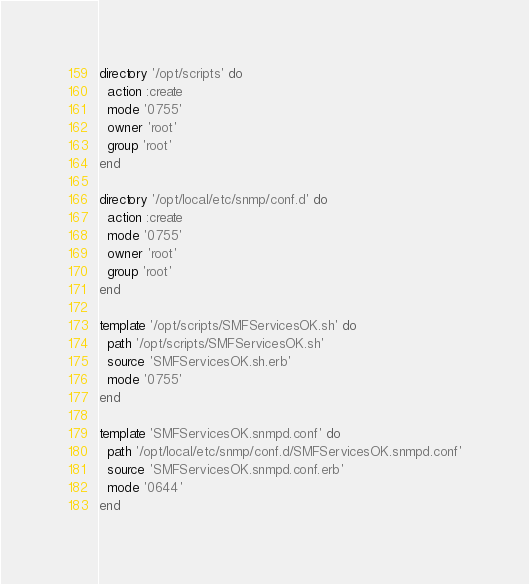<code> <loc_0><loc_0><loc_500><loc_500><_Ruby_>directory '/opt/scripts' do
  action :create
  mode '0755'
  owner 'root'
  group 'root'
end

directory '/opt/local/etc/snmp/conf.d' do
  action :create
  mode '0755'
  owner 'root'
  group 'root'
end

template '/opt/scripts/SMFServicesOK.sh' do
  path '/opt/scripts/SMFServicesOK.sh'
  source 'SMFServicesOK.sh.erb'
  mode '0755'
end

template 'SMFServicesOK.snmpd.conf' do
  path '/opt/local/etc/snmp/conf.d/SMFServicesOK.snmpd.conf'
  source 'SMFServicesOK.snmpd.conf.erb'
  mode '0644'
end
</code> 